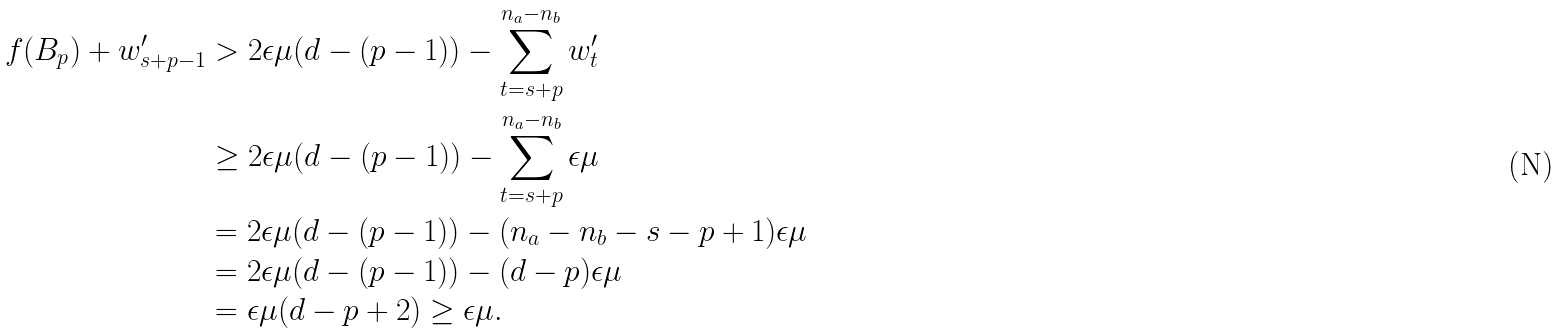<formula> <loc_0><loc_0><loc_500><loc_500>f ( B _ { p } ) + w ^ { \prime } _ { s + p - 1 } & > 2 \epsilon \mu ( d - ( p - 1 ) ) - \sum _ { t = s + p } ^ { n _ { a } - n _ { b } } w ^ { \prime } _ { t } \\ & \geq 2 \epsilon \mu ( d - ( p - 1 ) ) - \sum _ { t = s + p } ^ { n _ { a } - n _ { b } } \epsilon \mu \\ & = 2 \epsilon \mu ( d - ( p - 1 ) ) - ( n _ { a } - n _ { b } - s - p + 1 ) \epsilon \mu \\ & = 2 \epsilon \mu ( d - ( p - 1 ) ) - ( d - p ) \epsilon \mu \\ & = \epsilon \mu ( d - p + 2 ) \geq \epsilon \mu .</formula> 